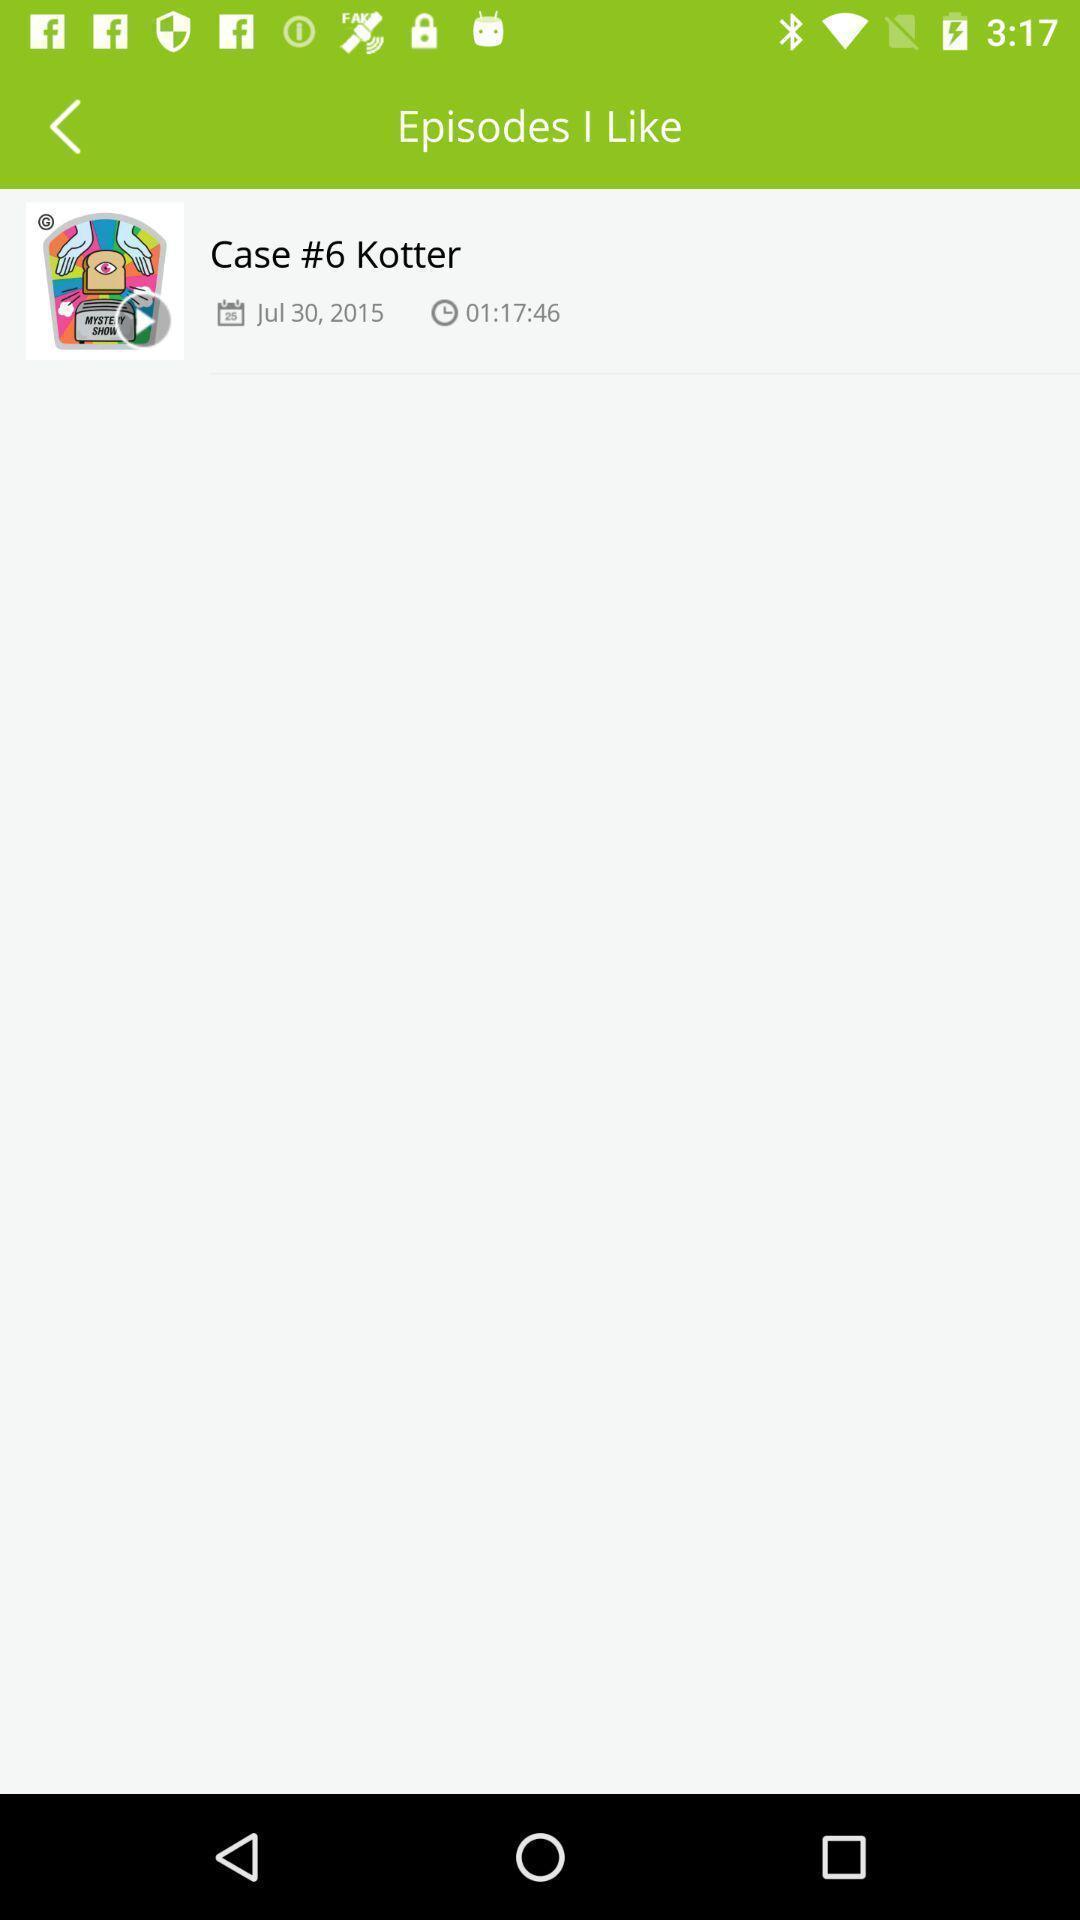Explain what's happening in this screen capture. Page displaying with episode in podcasts application. 